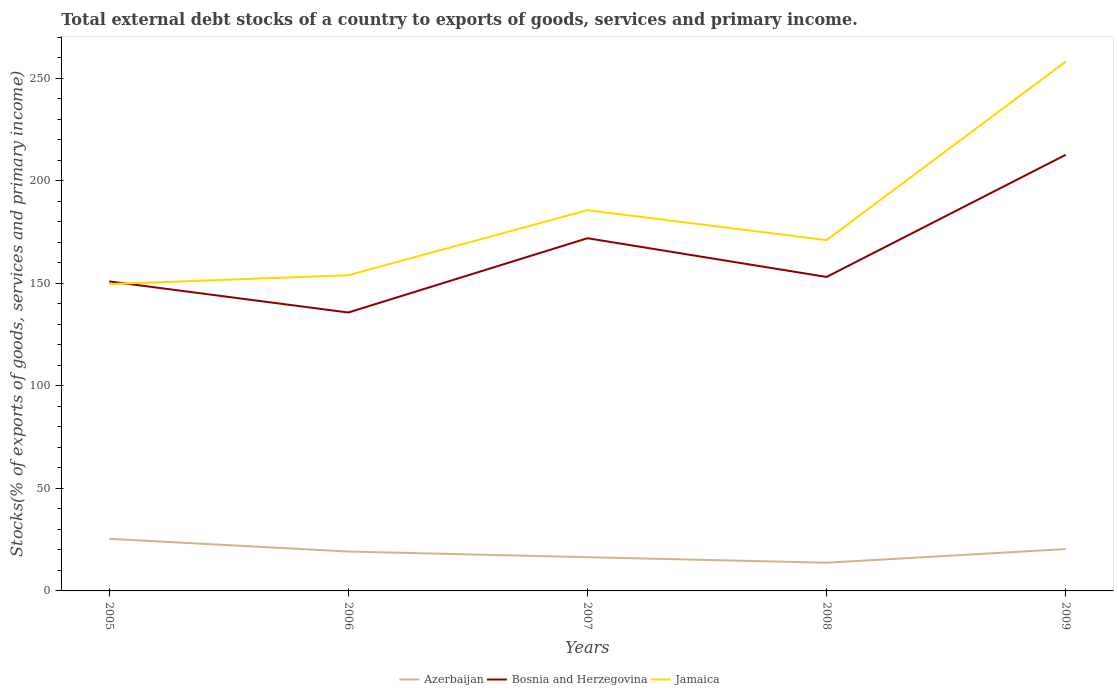Does the line corresponding to Bosnia and Herzegovina intersect with the line corresponding to Azerbaijan?
Offer a very short reply. No. Is the number of lines equal to the number of legend labels?
Your answer should be compact. Yes. Across all years, what is the maximum total debt stocks in Bosnia and Herzegovina?
Your answer should be very brief. 135.72. What is the total total debt stocks in Bosnia and Herzegovina in the graph?
Your answer should be very brief. -76.87. What is the difference between the highest and the second highest total debt stocks in Bosnia and Herzegovina?
Your answer should be compact. 76.87. Is the total debt stocks in Azerbaijan strictly greater than the total debt stocks in Jamaica over the years?
Offer a very short reply. Yes. How many lines are there?
Provide a succinct answer. 3. What is the difference between two consecutive major ticks on the Y-axis?
Provide a succinct answer. 50. Are the values on the major ticks of Y-axis written in scientific E-notation?
Make the answer very short. No. Does the graph contain any zero values?
Provide a short and direct response. No. Does the graph contain grids?
Your response must be concise. No. Where does the legend appear in the graph?
Provide a succinct answer. Bottom center. How many legend labels are there?
Your answer should be compact. 3. How are the legend labels stacked?
Keep it short and to the point. Horizontal. What is the title of the graph?
Make the answer very short. Total external debt stocks of a country to exports of goods, services and primary income. Does "Seychelles" appear as one of the legend labels in the graph?
Offer a very short reply. No. What is the label or title of the Y-axis?
Make the answer very short. Stocks(% of exports of goods, services and primary income). What is the Stocks(% of exports of goods, services and primary income) of Azerbaijan in 2005?
Give a very brief answer. 25.39. What is the Stocks(% of exports of goods, services and primary income) in Bosnia and Herzegovina in 2005?
Offer a very short reply. 150.89. What is the Stocks(% of exports of goods, services and primary income) in Jamaica in 2005?
Provide a succinct answer. 149.6. What is the Stocks(% of exports of goods, services and primary income) in Azerbaijan in 2006?
Your answer should be compact. 19.2. What is the Stocks(% of exports of goods, services and primary income) in Bosnia and Herzegovina in 2006?
Keep it short and to the point. 135.72. What is the Stocks(% of exports of goods, services and primary income) of Jamaica in 2006?
Your answer should be very brief. 153.89. What is the Stocks(% of exports of goods, services and primary income) in Azerbaijan in 2007?
Make the answer very short. 16.44. What is the Stocks(% of exports of goods, services and primary income) in Bosnia and Herzegovina in 2007?
Your answer should be very brief. 171.94. What is the Stocks(% of exports of goods, services and primary income) of Jamaica in 2007?
Ensure brevity in your answer.  185.61. What is the Stocks(% of exports of goods, services and primary income) of Azerbaijan in 2008?
Keep it short and to the point. 13.75. What is the Stocks(% of exports of goods, services and primary income) in Bosnia and Herzegovina in 2008?
Ensure brevity in your answer.  153.06. What is the Stocks(% of exports of goods, services and primary income) of Jamaica in 2008?
Provide a short and direct response. 171.03. What is the Stocks(% of exports of goods, services and primary income) in Azerbaijan in 2009?
Ensure brevity in your answer.  20.4. What is the Stocks(% of exports of goods, services and primary income) of Bosnia and Herzegovina in 2009?
Your response must be concise. 212.59. What is the Stocks(% of exports of goods, services and primary income) of Jamaica in 2009?
Your answer should be compact. 258.03. Across all years, what is the maximum Stocks(% of exports of goods, services and primary income) of Azerbaijan?
Give a very brief answer. 25.39. Across all years, what is the maximum Stocks(% of exports of goods, services and primary income) of Bosnia and Herzegovina?
Provide a succinct answer. 212.59. Across all years, what is the maximum Stocks(% of exports of goods, services and primary income) of Jamaica?
Offer a terse response. 258.03. Across all years, what is the minimum Stocks(% of exports of goods, services and primary income) of Azerbaijan?
Provide a short and direct response. 13.75. Across all years, what is the minimum Stocks(% of exports of goods, services and primary income) of Bosnia and Herzegovina?
Provide a succinct answer. 135.72. Across all years, what is the minimum Stocks(% of exports of goods, services and primary income) in Jamaica?
Make the answer very short. 149.6. What is the total Stocks(% of exports of goods, services and primary income) of Azerbaijan in the graph?
Offer a terse response. 95.18. What is the total Stocks(% of exports of goods, services and primary income) of Bosnia and Herzegovina in the graph?
Your answer should be compact. 824.21. What is the total Stocks(% of exports of goods, services and primary income) in Jamaica in the graph?
Offer a terse response. 918.16. What is the difference between the Stocks(% of exports of goods, services and primary income) of Azerbaijan in 2005 and that in 2006?
Ensure brevity in your answer.  6.19. What is the difference between the Stocks(% of exports of goods, services and primary income) of Bosnia and Herzegovina in 2005 and that in 2006?
Your answer should be very brief. 15.17. What is the difference between the Stocks(% of exports of goods, services and primary income) of Jamaica in 2005 and that in 2006?
Provide a succinct answer. -4.29. What is the difference between the Stocks(% of exports of goods, services and primary income) in Azerbaijan in 2005 and that in 2007?
Your response must be concise. 8.96. What is the difference between the Stocks(% of exports of goods, services and primary income) of Bosnia and Herzegovina in 2005 and that in 2007?
Offer a very short reply. -21.05. What is the difference between the Stocks(% of exports of goods, services and primary income) of Jamaica in 2005 and that in 2007?
Give a very brief answer. -36.01. What is the difference between the Stocks(% of exports of goods, services and primary income) of Azerbaijan in 2005 and that in 2008?
Offer a terse response. 11.65. What is the difference between the Stocks(% of exports of goods, services and primary income) of Bosnia and Herzegovina in 2005 and that in 2008?
Provide a succinct answer. -2.17. What is the difference between the Stocks(% of exports of goods, services and primary income) in Jamaica in 2005 and that in 2008?
Your answer should be compact. -21.42. What is the difference between the Stocks(% of exports of goods, services and primary income) of Azerbaijan in 2005 and that in 2009?
Provide a succinct answer. 5. What is the difference between the Stocks(% of exports of goods, services and primary income) in Bosnia and Herzegovina in 2005 and that in 2009?
Provide a succinct answer. -61.7. What is the difference between the Stocks(% of exports of goods, services and primary income) in Jamaica in 2005 and that in 2009?
Keep it short and to the point. -108.42. What is the difference between the Stocks(% of exports of goods, services and primary income) in Azerbaijan in 2006 and that in 2007?
Keep it short and to the point. 2.77. What is the difference between the Stocks(% of exports of goods, services and primary income) of Bosnia and Herzegovina in 2006 and that in 2007?
Offer a terse response. -36.22. What is the difference between the Stocks(% of exports of goods, services and primary income) in Jamaica in 2006 and that in 2007?
Your answer should be compact. -31.72. What is the difference between the Stocks(% of exports of goods, services and primary income) of Azerbaijan in 2006 and that in 2008?
Make the answer very short. 5.46. What is the difference between the Stocks(% of exports of goods, services and primary income) in Bosnia and Herzegovina in 2006 and that in 2008?
Keep it short and to the point. -17.34. What is the difference between the Stocks(% of exports of goods, services and primary income) of Jamaica in 2006 and that in 2008?
Provide a short and direct response. -17.13. What is the difference between the Stocks(% of exports of goods, services and primary income) in Azerbaijan in 2006 and that in 2009?
Your answer should be compact. -1.19. What is the difference between the Stocks(% of exports of goods, services and primary income) in Bosnia and Herzegovina in 2006 and that in 2009?
Offer a terse response. -76.87. What is the difference between the Stocks(% of exports of goods, services and primary income) in Jamaica in 2006 and that in 2009?
Provide a short and direct response. -104.13. What is the difference between the Stocks(% of exports of goods, services and primary income) of Azerbaijan in 2007 and that in 2008?
Make the answer very short. 2.69. What is the difference between the Stocks(% of exports of goods, services and primary income) of Bosnia and Herzegovina in 2007 and that in 2008?
Provide a short and direct response. 18.88. What is the difference between the Stocks(% of exports of goods, services and primary income) of Jamaica in 2007 and that in 2008?
Your answer should be compact. 14.59. What is the difference between the Stocks(% of exports of goods, services and primary income) in Azerbaijan in 2007 and that in 2009?
Offer a terse response. -3.96. What is the difference between the Stocks(% of exports of goods, services and primary income) in Bosnia and Herzegovina in 2007 and that in 2009?
Give a very brief answer. -40.65. What is the difference between the Stocks(% of exports of goods, services and primary income) of Jamaica in 2007 and that in 2009?
Offer a very short reply. -72.41. What is the difference between the Stocks(% of exports of goods, services and primary income) of Azerbaijan in 2008 and that in 2009?
Your answer should be compact. -6.65. What is the difference between the Stocks(% of exports of goods, services and primary income) in Bosnia and Herzegovina in 2008 and that in 2009?
Make the answer very short. -59.53. What is the difference between the Stocks(% of exports of goods, services and primary income) in Jamaica in 2008 and that in 2009?
Offer a terse response. -87. What is the difference between the Stocks(% of exports of goods, services and primary income) in Azerbaijan in 2005 and the Stocks(% of exports of goods, services and primary income) in Bosnia and Herzegovina in 2006?
Your response must be concise. -110.33. What is the difference between the Stocks(% of exports of goods, services and primary income) in Azerbaijan in 2005 and the Stocks(% of exports of goods, services and primary income) in Jamaica in 2006?
Ensure brevity in your answer.  -128.5. What is the difference between the Stocks(% of exports of goods, services and primary income) of Bosnia and Herzegovina in 2005 and the Stocks(% of exports of goods, services and primary income) of Jamaica in 2006?
Ensure brevity in your answer.  -3. What is the difference between the Stocks(% of exports of goods, services and primary income) of Azerbaijan in 2005 and the Stocks(% of exports of goods, services and primary income) of Bosnia and Herzegovina in 2007?
Your response must be concise. -146.55. What is the difference between the Stocks(% of exports of goods, services and primary income) in Azerbaijan in 2005 and the Stocks(% of exports of goods, services and primary income) in Jamaica in 2007?
Your answer should be compact. -160.22. What is the difference between the Stocks(% of exports of goods, services and primary income) in Bosnia and Herzegovina in 2005 and the Stocks(% of exports of goods, services and primary income) in Jamaica in 2007?
Offer a very short reply. -34.72. What is the difference between the Stocks(% of exports of goods, services and primary income) of Azerbaijan in 2005 and the Stocks(% of exports of goods, services and primary income) of Bosnia and Herzegovina in 2008?
Your answer should be compact. -127.67. What is the difference between the Stocks(% of exports of goods, services and primary income) in Azerbaijan in 2005 and the Stocks(% of exports of goods, services and primary income) in Jamaica in 2008?
Provide a succinct answer. -145.63. What is the difference between the Stocks(% of exports of goods, services and primary income) in Bosnia and Herzegovina in 2005 and the Stocks(% of exports of goods, services and primary income) in Jamaica in 2008?
Give a very brief answer. -20.13. What is the difference between the Stocks(% of exports of goods, services and primary income) of Azerbaijan in 2005 and the Stocks(% of exports of goods, services and primary income) of Bosnia and Herzegovina in 2009?
Offer a very short reply. -187.2. What is the difference between the Stocks(% of exports of goods, services and primary income) of Azerbaijan in 2005 and the Stocks(% of exports of goods, services and primary income) of Jamaica in 2009?
Ensure brevity in your answer.  -232.63. What is the difference between the Stocks(% of exports of goods, services and primary income) of Bosnia and Herzegovina in 2005 and the Stocks(% of exports of goods, services and primary income) of Jamaica in 2009?
Provide a short and direct response. -107.13. What is the difference between the Stocks(% of exports of goods, services and primary income) of Azerbaijan in 2006 and the Stocks(% of exports of goods, services and primary income) of Bosnia and Herzegovina in 2007?
Ensure brevity in your answer.  -152.74. What is the difference between the Stocks(% of exports of goods, services and primary income) in Azerbaijan in 2006 and the Stocks(% of exports of goods, services and primary income) in Jamaica in 2007?
Offer a very short reply. -166.41. What is the difference between the Stocks(% of exports of goods, services and primary income) in Bosnia and Herzegovina in 2006 and the Stocks(% of exports of goods, services and primary income) in Jamaica in 2007?
Your answer should be very brief. -49.89. What is the difference between the Stocks(% of exports of goods, services and primary income) in Azerbaijan in 2006 and the Stocks(% of exports of goods, services and primary income) in Bosnia and Herzegovina in 2008?
Your answer should be compact. -133.86. What is the difference between the Stocks(% of exports of goods, services and primary income) in Azerbaijan in 2006 and the Stocks(% of exports of goods, services and primary income) in Jamaica in 2008?
Offer a terse response. -151.82. What is the difference between the Stocks(% of exports of goods, services and primary income) of Bosnia and Herzegovina in 2006 and the Stocks(% of exports of goods, services and primary income) of Jamaica in 2008?
Ensure brevity in your answer.  -35.3. What is the difference between the Stocks(% of exports of goods, services and primary income) in Azerbaijan in 2006 and the Stocks(% of exports of goods, services and primary income) in Bosnia and Herzegovina in 2009?
Offer a very short reply. -193.39. What is the difference between the Stocks(% of exports of goods, services and primary income) in Azerbaijan in 2006 and the Stocks(% of exports of goods, services and primary income) in Jamaica in 2009?
Provide a short and direct response. -238.82. What is the difference between the Stocks(% of exports of goods, services and primary income) of Bosnia and Herzegovina in 2006 and the Stocks(% of exports of goods, services and primary income) of Jamaica in 2009?
Your response must be concise. -122.3. What is the difference between the Stocks(% of exports of goods, services and primary income) in Azerbaijan in 2007 and the Stocks(% of exports of goods, services and primary income) in Bosnia and Herzegovina in 2008?
Ensure brevity in your answer.  -136.62. What is the difference between the Stocks(% of exports of goods, services and primary income) of Azerbaijan in 2007 and the Stocks(% of exports of goods, services and primary income) of Jamaica in 2008?
Your answer should be very brief. -154.59. What is the difference between the Stocks(% of exports of goods, services and primary income) in Bosnia and Herzegovina in 2007 and the Stocks(% of exports of goods, services and primary income) in Jamaica in 2008?
Provide a short and direct response. 0.92. What is the difference between the Stocks(% of exports of goods, services and primary income) of Azerbaijan in 2007 and the Stocks(% of exports of goods, services and primary income) of Bosnia and Herzegovina in 2009?
Your response must be concise. -196.15. What is the difference between the Stocks(% of exports of goods, services and primary income) in Azerbaijan in 2007 and the Stocks(% of exports of goods, services and primary income) in Jamaica in 2009?
Your response must be concise. -241.59. What is the difference between the Stocks(% of exports of goods, services and primary income) of Bosnia and Herzegovina in 2007 and the Stocks(% of exports of goods, services and primary income) of Jamaica in 2009?
Provide a short and direct response. -86.08. What is the difference between the Stocks(% of exports of goods, services and primary income) of Azerbaijan in 2008 and the Stocks(% of exports of goods, services and primary income) of Bosnia and Herzegovina in 2009?
Offer a terse response. -198.84. What is the difference between the Stocks(% of exports of goods, services and primary income) in Azerbaijan in 2008 and the Stocks(% of exports of goods, services and primary income) in Jamaica in 2009?
Ensure brevity in your answer.  -244.28. What is the difference between the Stocks(% of exports of goods, services and primary income) of Bosnia and Herzegovina in 2008 and the Stocks(% of exports of goods, services and primary income) of Jamaica in 2009?
Provide a succinct answer. -104.96. What is the average Stocks(% of exports of goods, services and primary income) of Azerbaijan per year?
Offer a terse response. 19.04. What is the average Stocks(% of exports of goods, services and primary income) in Bosnia and Herzegovina per year?
Ensure brevity in your answer.  164.84. What is the average Stocks(% of exports of goods, services and primary income) in Jamaica per year?
Ensure brevity in your answer.  183.63. In the year 2005, what is the difference between the Stocks(% of exports of goods, services and primary income) in Azerbaijan and Stocks(% of exports of goods, services and primary income) in Bosnia and Herzegovina?
Offer a very short reply. -125.5. In the year 2005, what is the difference between the Stocks(% of exports of goods, services and primary income) in Azerbaijan and Stocks(% of exports of goods, services and primary income) in Jamaica?
Keep it short and to the point. -124.21. In the year 2005, what is the difference between the Stocks(% of exports of goods, services and primary income) in Bosnia and Herzegovina and Stocks(% of exports of goods, services and primary income) in Jamaica?
Provide a succinct answer. 1.29. In the year 2006, what is the difference between the Stocks(% of exports of goods, services and primary income) of Azerbaijan and Stocks(% of exports of goods, services and primary income) of Bosnia and Herzegovina?
Provide a short and direct response. -116.52. In the year 2006, what is the difference between the Stocks(% of exports of goods, services and primary income) of Azerbaijan and Stocks(% of exports of goods, services and primary income) of Jamaica?
Your response must be concise. -134.69. In the year 2006, what is the difference between the Stocks(% of exports of goods, services and primary income) of Bosnia and Herzegovina and Stocks(% of exports of goods, services and primary income) of Jamaica?
Your answer should be very brief. -18.17. In the year 2007, what is the difference between the Stocks(% of exports of goods, services and primary income) in Azerbaijan and Stocks(% of exports of goods, services and primary income) in Bosnia and Herzegovina?
Give a very brief answer. -155.5. In the year 2007, what is the difference between the Stocks(% of exports of goods, services and primary income) of Azerbaijan and Stocks(% of exports of goods, services and primary income) of Jamaica?
Keep it short and to the point. -169.17. In the year 2007, what is the difference between the Stocks(% of exports of goods, services and primary income) of Bosnia and Herzegovina and Stocks(% of exports of goods, services and primary income) of Jamaica?
Your answer should be compact. -13.67. In the year 2008, what is the difference between the Stocks(% of exports of goods, services and primary income) of Azerbaijan and Stocks(% of exports of goods, services and primary income) of Bosnia and Herzegovina?
Offer a terse response. -139.31. In the year 2008, what is the difference between the Stocks(% of exports of goods, services and primary income) in Azerbaijan and Stocks(% of exports of goods, services and primary income) in Jamaica?
Give a very brief answer. -157.28. In the year 2008, what is the difference between the Stocks(% of exports of goods, services and primary income) of Bosnia and Herzegovina and Stocks(% of exports of goods, services and primary income) of Jamaica?
Make the answer very short. -17.96. In the year 2009, what is the difference between the Stocks(% of exports of goods, services and primary income) of Azerbaijan and Stocks(% of exports of goods, services and primary income) of Bosnia and Herzegovina?
Make the answer very short. -192.19. In the year 2009, what is the difference between the Stocks(% of exports of goods, services and primary income) in Azerbaijan and Stocks(% of exports of goods, services and primary income) in Jamaica?
Provide a succinct answer. -237.63. In the year 2009, what is the difference between the Stocks(% of exports of goods, services and primary income) in Bosnia and Herzegovina and Stocks(% of exports of goods, services and primary income) in Jamaica?
Keep it short and to the point. -45.43. What is the ratio of the Stocks(% of exports of goods, services and primary income) of Azerbaijan in 2005 to that in 2006?
Provide a short and direct response. 1.32. What is the ratio of the Stocks(% of exports of goods, services and primary income) of Bosnia and Herzegovina in 2005 to that in 2006?
Offer a terse response. 1.11. What is the ratio of the Stocks(% of exports of goods, services and primary income) in Jamaica in 2005 to that in 2006?
Offer a very short reply. 0.97. What is the ratio of the Stocks(% of exports of goods, services and primary income) in Azerbaijan in 2005 to that in 2007?
Offer a terse response. 1.54. What is the ratio of the Stocks(% of exports of goods, services and primary income) in Bosnia and Herzegovina in 2005 to that in 2007?
Keep it short and to the point. 0.88. What is the ratio of the Stocks(% of exports of goods, services and primary income) of Jamaica in 2005 to that in 2007?
Ensure brevity in your answer.  0.81. What is the ratio of the Stocks(% of exports of goods, services and primary income) in Azerbaijan in 2005 to that in 2008?
Provide a short and direct response. 1.85. What is the ratio of the Stocks(% of exports of goods, services and primary income) in Bosnia and Herzegovina in 2005 to that in 2008?
Your answer should be compact. 0.99. What is the ratio of the Stocks(% of exports of goods, services and primary income) in Jamaica in 2005 to that in 2008?
Ensure brevity in your answer.  0.87. What is the ratio of the Stocks(% of exports of goods, services and primary income) in Azerbaijan in 2005 to that in 2009?
Offer a very short reply. 1.25. What is the ratio of the Stocks(% of exports of goods, services and primary income) in Bosnia and Herzegovina in 2005 to that in 2009?
Make the answer very short. 0.71. What is the ratio of the Stocks(% of exports of goods, services and primary income) of Jamaica in 2005 to that in 2009?
Your answer should be very brief. 0.58. What is the ratio of the Stocks(% of exports of goods, services and primary income) of Azerbaijan in 2006 to that in 2007?
Give a very brief answer. 1.17. What is the ratio of the Stocks(% of exports of goods, services and primary income) in Bosnia and Herzegovina in 2006 to that in 2007?
Ensure brevity in your answer.  0.79. What is the ratio of the Stocks(% of exports of goods, services and primary income) in Jamaica in 2006 to that in 2007?
Give a very brief answer. 0.83. What is the ratio of the Stocks(% of exports of goods, services and primary income) of Azerbaijan in 2006 to that in 2008?
Provide a short and direct response. 1.4. What is the ratio of the Stocks(% of exports of goods, services and primary income) in Bosnia and Herzegovina in 2006 to that in 2008?
Provide a succinct answer. 0.89. What is the ratio of the Stocks(% of exports of goods, services and primary income) of Jamaica in 2006 to that in 2008?
Offer a terse response. 0.9. What is the ratio of the Stocks(% of exports of goods, services and primary income) in Azerbaijan in 2006 to that in 2009?
Your response must be concise. 0.94. What is the ratio of the Stocks(% of exports of goods, services and primary income) of Bosnia and Herzegovina in 2006 to that in 2009?
Your response must be concise. 0.64. What is the ratio of the Stocks(% of exports of goods, services and primary income) of Jamaica in 2006 to that in 2009?
Offer a very short reply. 0.6. What is the ratio of the Stocks(% of exports of goods, services and primary income) in Azerbaijan in 2007 to that in 2008?
Offer a terse response. 1.2. What is the ratio of the Stocks(% of exports of goods, services and primary income) of Bosnia and Herzegovina in 2007 to that in 2008?
Your response must be concise. 1.12. What is the ratio of the Stocks(% of exports of goods, services and primary income) of Jamaica in 2007 to that in 2008?
Provide a succinct answer. 1.09. What is the ratio of the Stocks(% of exports of goods, services and primary income) of Azerbaijan in 2007 to that in 2009?
Offer a terse response. 0.81. What is the ratio of the Stocks(% of exports of goods, services and primary income) of Bosnia and Herzegovina in 2007 to that in 2009?
Ensure brevity in your answer.  0.81. What is the ratio of the Stocks(% of exports of goods, services and primary income) in Jamaica in 2007 to that in 2009?
Make the answer very short. 0.72. What is the ratio of the Stocks(% of exports of goods, services and primary income) of Azerbaijan in 2008 to that in 2009?
Your answer should be very brief. 0.67. What is the ratio of the Stocks(% of exports of goods, services and primary income) in Bosnia and Herzegovina in 2008 to that in 2009?
Keep it short and to the point. 0.72. What is the ratio of the Stocks(% of exports of goods, services and primary income) in Jamaica in 2008 to that in 2009?
Ensure brevity in your answer.  0.66. What is the difference between the highest and the second highest Stocks(% of exports of goods, services and primary income) in Azerbaijan?
Provide a succinct answer. 5. What is the difference between the highest and the second highest Stocks(% of exports of goods, services and primary income) of Bosnia and Herzegovina?
Your answer should be compact. 40.65. What is the difference between the highest and the second highest Stocks(% of exports of goods, services and primary income) in Jamaica?
Offer a terse response. 72.41. What is the difference between the highest and the lowest Stocks(% of exports of goods, services and primary income) of Azerbaijan?
Give a very brief answer. 11.65. What is the difference between the highest and the lowest Stocks(% of exports of goods, services and primary income) in Bosnia and Herzegovina?
Make the answer very short. 76.87. What is the difference between the highest and the lowest Stocks(% of exports of goods, services and primary income) of Jamaica?
Ensure brevity in your answer.  108.42. 